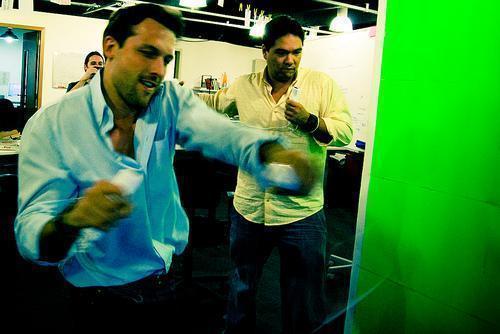What activity is the individual engaging in?
Choose the correct response, then elucidate: 'Answer: answer
Rationale: rationale.'
Options: Running, boxing, taekwondo, climbing. Answer: boxing.
Rationale: He is holding video game controllers and has his arms in a stance that someone would be in when boxing. 